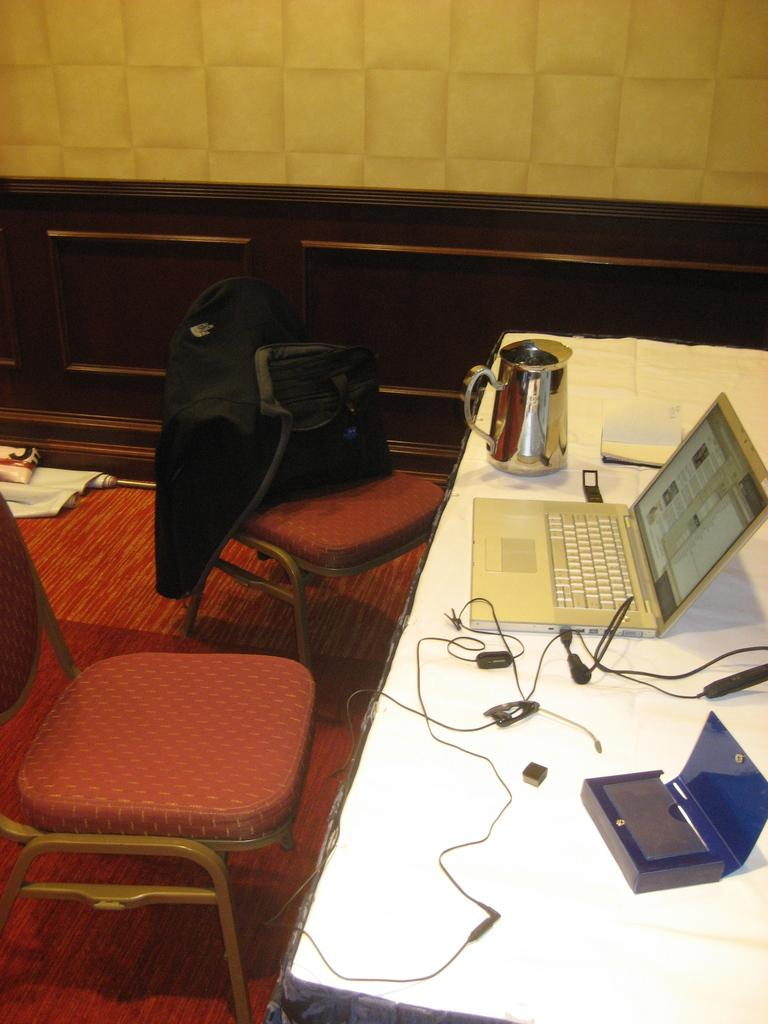What piece of furniture is in the image? There is a table in the image. What object is on the table? A bag, earphones, a laptop, and a jar are on the table. How many chairs are at the left side of the table? There are two chairs at the left side of the table. What is covering one of the chairs? A cloth is covering one of the chairs. What type of chicken is on the tray in the image? There is no chicken or tray present in the image. What season is depicted in the image? The image does not depict a specific season; it only shows a table with various objects on it. 